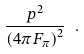Convert formula to latex. <formula><loc_0><loc_0><loc_500><loc_500>\frac { p ^ { 2 } } { \left ( 4 \pi F _ { \pi } \right ) ^ { 2 } } \ .</formula> 